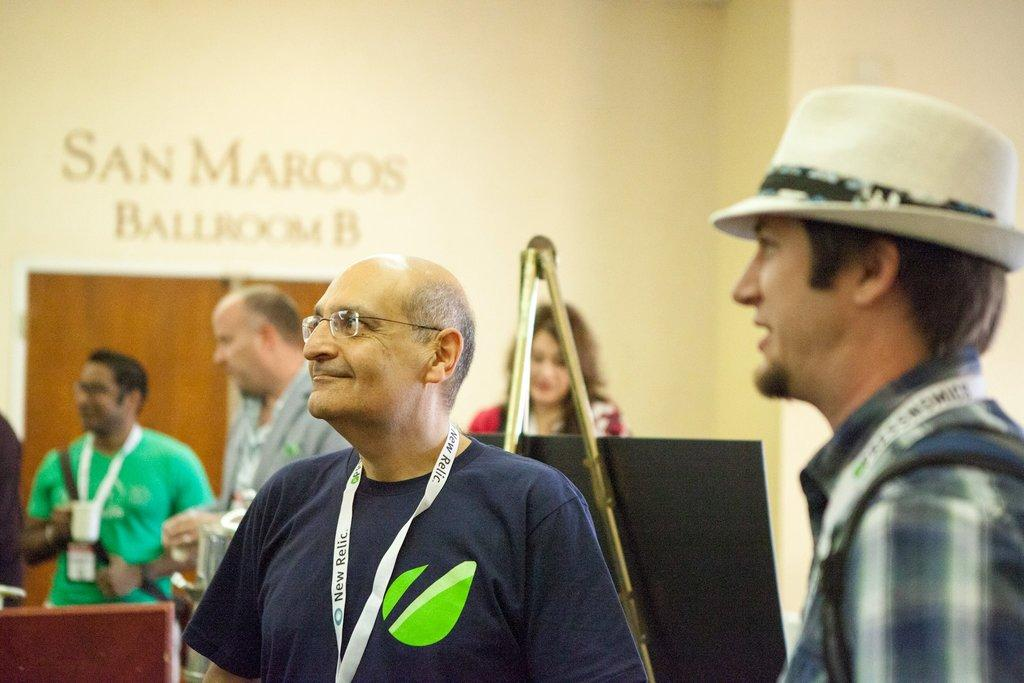What is the position of the person wearing a hat in the image? The person wearing a hat is on the right side of the image. Can you describe the person standing in the center of the image? There is a person standing in the center of the image. What can be observed about the background of the image? The background of the image is blurred. What other elements can be seen in the background of the image? There are people, a stand, a board, a door, and a wall in the background of the image. What type of pigs are being fed by the person wearing a hat in the image? There are no pigs present in the image; it features a person wearing a hat and another person standing in the center. 